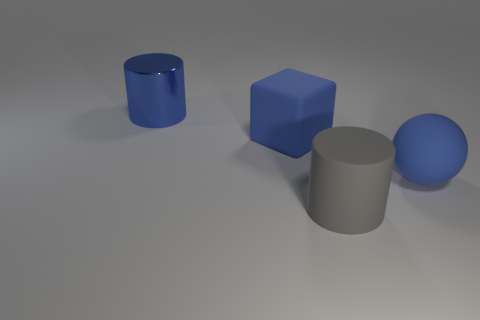Add 2 big blue objects. How many objects exist? 6 Subtract all blocks. How many objects are left? 3 Subtract 1 blue cylinders. How many objects are left? 3 Subtract all blue rubber cubes. Subtract all large blue matte things. How many objects are left? 1 Add 2 blue spheres. How many blue spheres are left? 3 Add 1 metal objects. How many metal objects exist? 2 